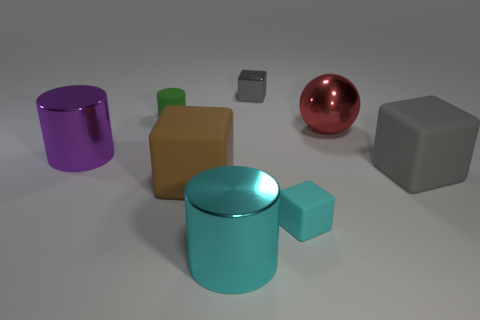There is a shiny object left of the metallic cylinder in front of the large gray thing that is on the right side of the green rubber thing; what is its shape?
Give a very brief answer. Cylinder. What size is the brown thing that is the same shape as the gray shiny thing?
Keep it short and to the point. Large. There is a matte block that is both behind the cyan cube and on the left side of the big red shiny thing; what size is it?
Provide a short and direct response. Large. There is a big object that is the same color as the small rubber cube; what shape is it?
Provide a short and direct response. Cylinder. What is the color of the small cylinder?
Your answer should be compact. Green. There is a shiny thing that is on the right side of the small gray shiny block; how big is it?
Offer a terse response. Large. How many red shiny things are in front of the big rubber thing in front of the thing that is on the right side of the big red metal ball?
Provide a succinct answer. 0. What color is the shiny cylinder on the right side of the big cylinder that is behind the large cyan cylinder?
Your answer should be compact. Cyan. Is there a matte cube that has the same size as the gray shiny cube?
Your response must be concise. Yes. The large cylinder behind the cyan cylinder that is in front of the big metallic cylinder on the left side of the green matte thing is made of what material?
Provide a short and direct response. Metal. 